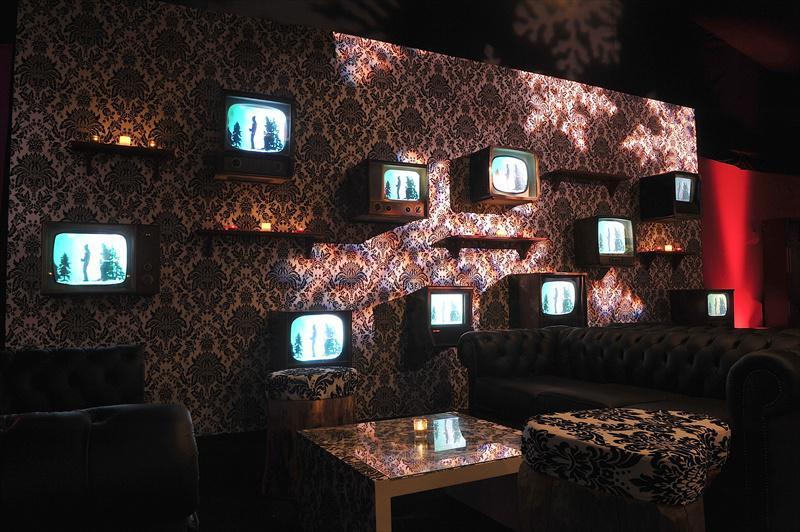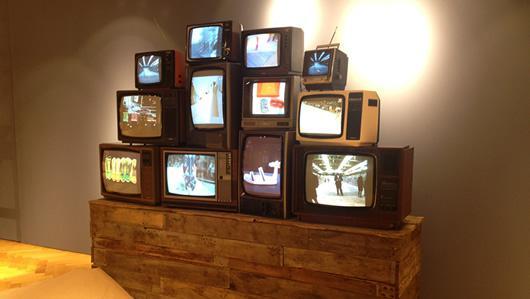The first image is the image on the left, the second image is the image on the right. Considering the images on both sides, is "There is at least one tv with rainbow stripes on the screen" valid? Answer yes or no. No. The first image is the image on the left, the second image is the image on the right. Evaluate the accuracy of this statement regarding the images: "The right image shows four stacked rows of same-model TVs, and at least one TV has a gray screen and at least one TV has a rainbow 'test pattern'.". Is it true? Answer yes or no. No. 